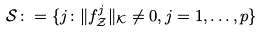<formula> <loc_0><loc_0><loc_500><loc_500>\mathcal { S } \colon = \{ j \colon \| f _ { \mathcal { Z } } ^ { j } \| _ { \mathcal { K } } \neq 0 , j = 1 , \dots , p \}</formula> 